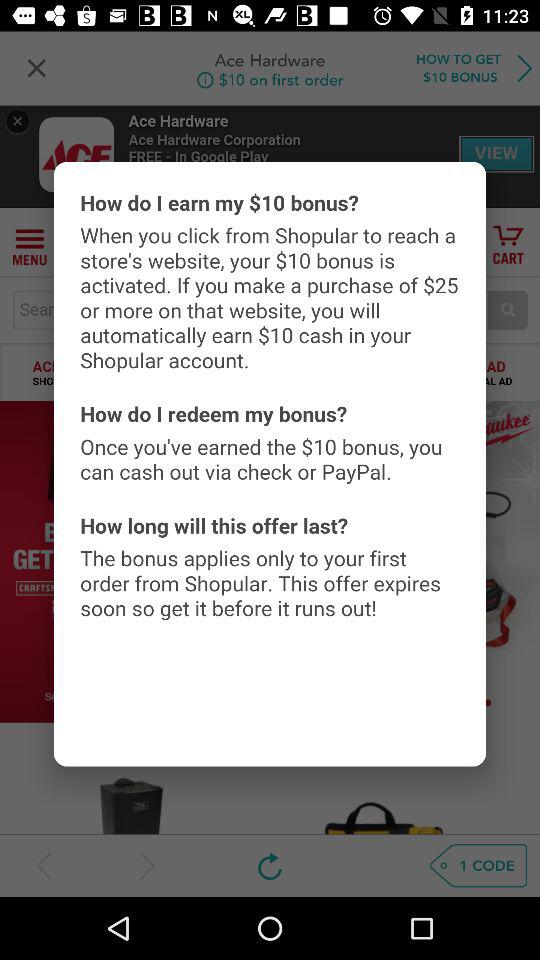When is the bonus offer applicable? The bonus offer is applicable only to your first order from Shopular. 